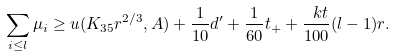<formula> <loc_0><loc_0><loc_500><loc_500>\sum _ { i \leq l } \mu _ { i } \geq u ( K _ { 3 5 } r ^ { 2 / 3 } , A ) + \frac { 1 } { 1 0 } d ^ { \prime } + \frac { 1 } { 6 0 } t _ { + } + \frac { \ k t } { 1 0 0 } ( l - 1 ) r .</formula> 